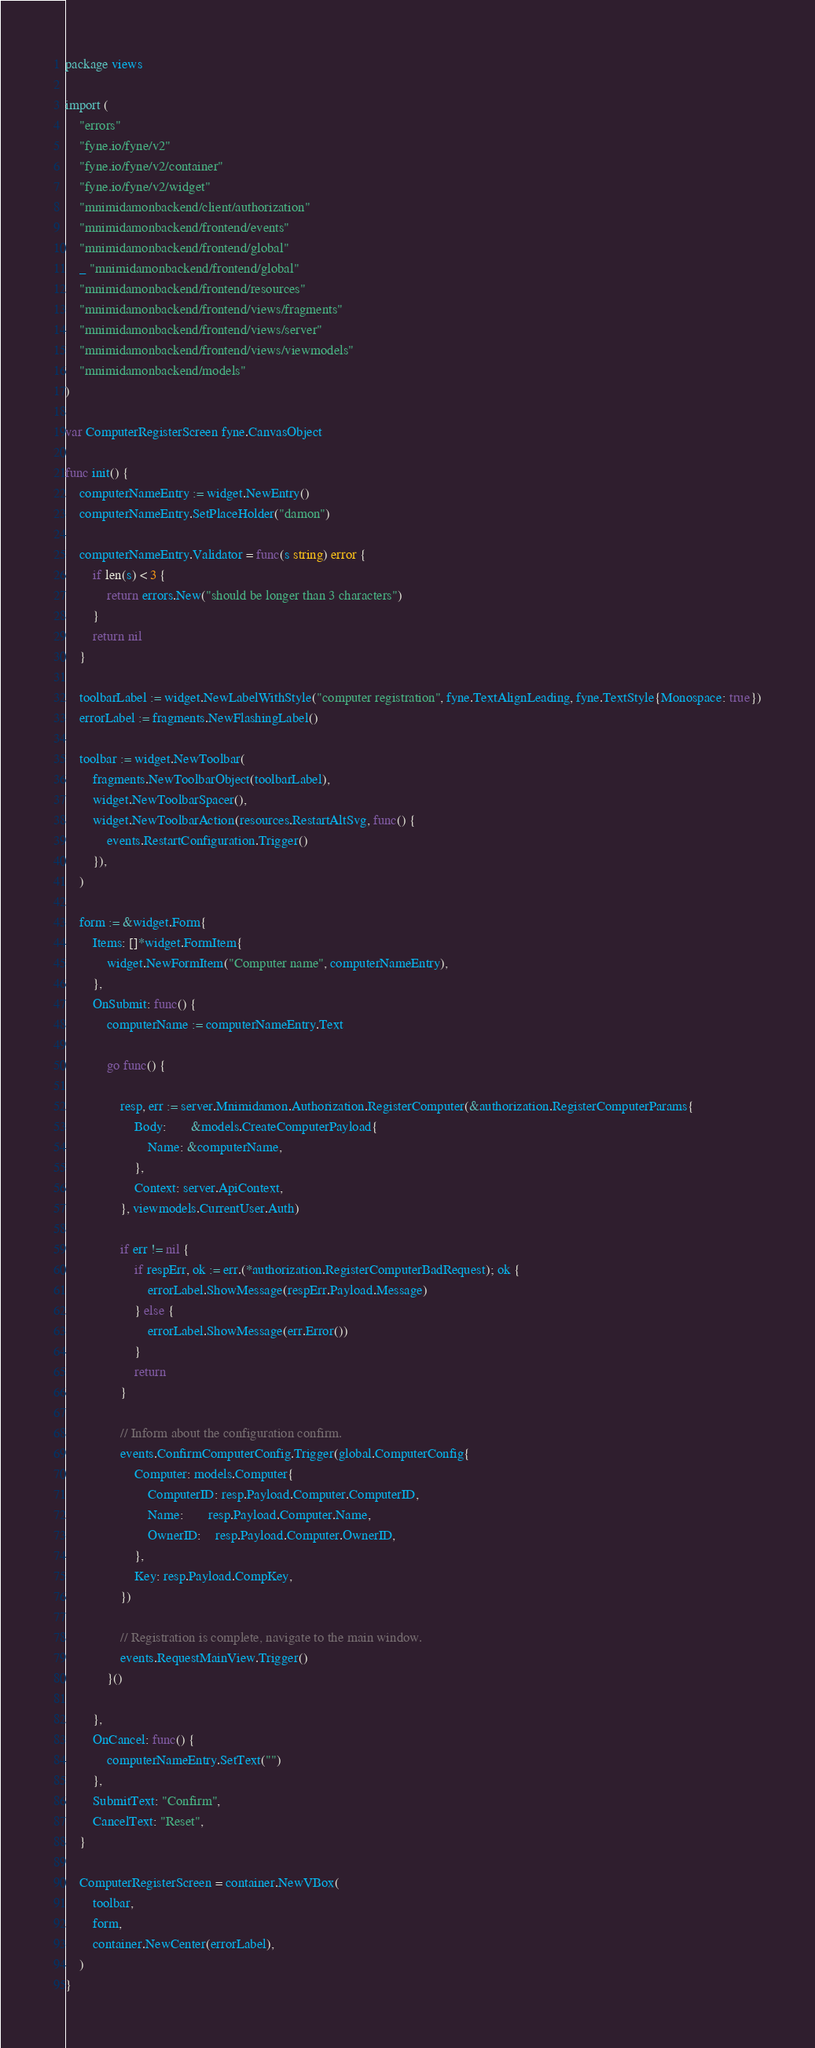Convert code to text. <code><loc_0><loc_0><loc_500><loc_500><_Go_>package views

import (
	"errors"
	"fyne.io/fyne/v2"
	"fyne.io/fyne/v2/container"
	"fyne.io/fyne/v2/widget"
	"mnimidamonbackend/client/authorization"
	"mnimidamonbackend/frontend/events"
	"mnimidamonbackend/frontend/global"
	_ "mnimidamonbackend/frontend/global"
	"mnimidamonbackend/frontend/resources"
	"mnimidamonbackend/frontend/views/fragments"
	"mnimidamonbackend/frontend/views/server"
	"mnimidamonbackend/frontend/views/viewmodels"
	"mnimidamonbackend/models"
)

var ComputerRegisterScreen fyne.CanvasObject

func init() {
	computerNameEntry := widget.NewEntry()
	computerNameEntry.SetPlaceHolder("damon")

	computerNameEntry.Validator = func(s string) error {
		if len(s) < 3 {
			return errors.New("should be longer than 3 characters")
		}
		return nil
	}

	toolbarLabel := widget.NewLabelWithStyle("computer registration", fyne.TextAlignLeading, fyne.TextStyle{Monospace: true})
	errorLabel := fragments.NewFlashingLabel()

	toolbar := widget.NewToolbar(
		fragments.NewToolbarObject(toolbarLabel),
		widget.NewToolbarSpacer(),
		widget.NewToolbarAction(resources.RestartAltSvg, func() {
			events.RestartConfiguration.Trigger()
		}),
	)

	form := &widget.Form{
		Items: []*widget.FormItem{
			widget.NewFormItem("Computer name", computerNameEntry),
		},
		OnSubmit: func() {
			computerName := computerNameEntry.Text

			go func() {

				resp, err := server.Mnimidamon.Authorization.RegisterComputer(&authorization.RegisterComputerParams{
					Body:       &models.CreateComputerPayload{
						Name: &computerName,
					},
					Context: server.ApiContext,
				}, viewmodels.CurrentUser.Auth)

				if err != nil {
					if respErr, ok := err.(*authorization.RegisterComputerBadRequest); ok {
						errorLabel.ShowMessage(respErr.Payload.Message)
					} else {
						errorLabel.ShowMessage(err.Error())
					}
					return
				}

				// Inform about the configuration confirm.
				events.ConfirmComputerConfig.Trigger(global.ComputerConfig{
					Computer: models.Computer{
						ComputerID: resp.Payload.Computer.ComputerID,
						Name:       resp.Payload.Computer.Name,
						OwnerID:    resp.Payload.Computer.OwnerID,
					},
					Key: resp.Payload.CompKey,
				})

				// Registration is complete, navigate to the main window.
				events.RequestMainView.Trigger()
			}()

		},
		OnCancel: func() {
			computerNameEntry.SetText("")
		},
		SubmitText: "Confirm",
		CancelText: "Reset",
	}

	ComputerRegisterScreen = container.NewVBox(
		toolbar,
		form,
		container.NewCenter(errorLabel),
	)
}
</code> 